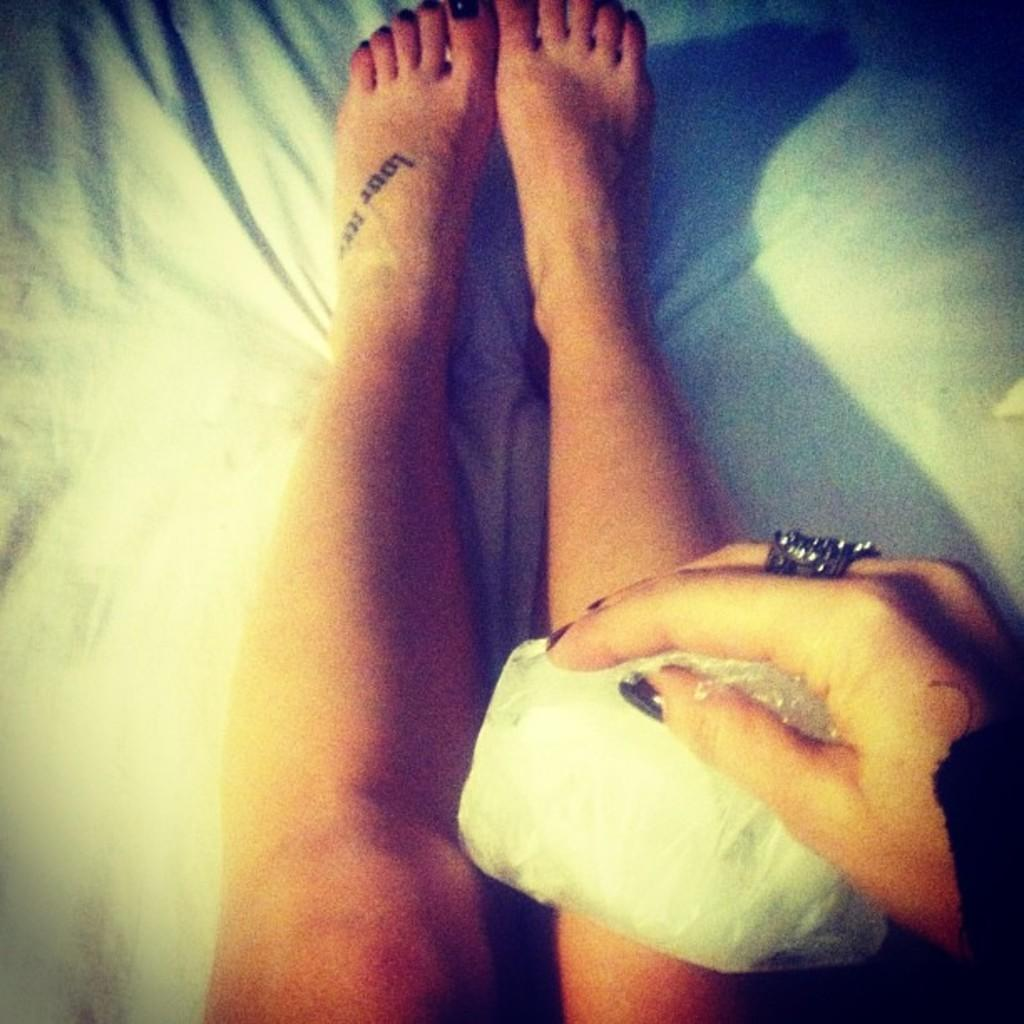What is the main subject of the image? The main subject of the image is a person's legs on a bed. Can you describe any other objects or elements in the image? Yes, there is a hand holding a paper in the bottom right corner of the image. What type of pump is visible in the image? There is no pump present in the image. 